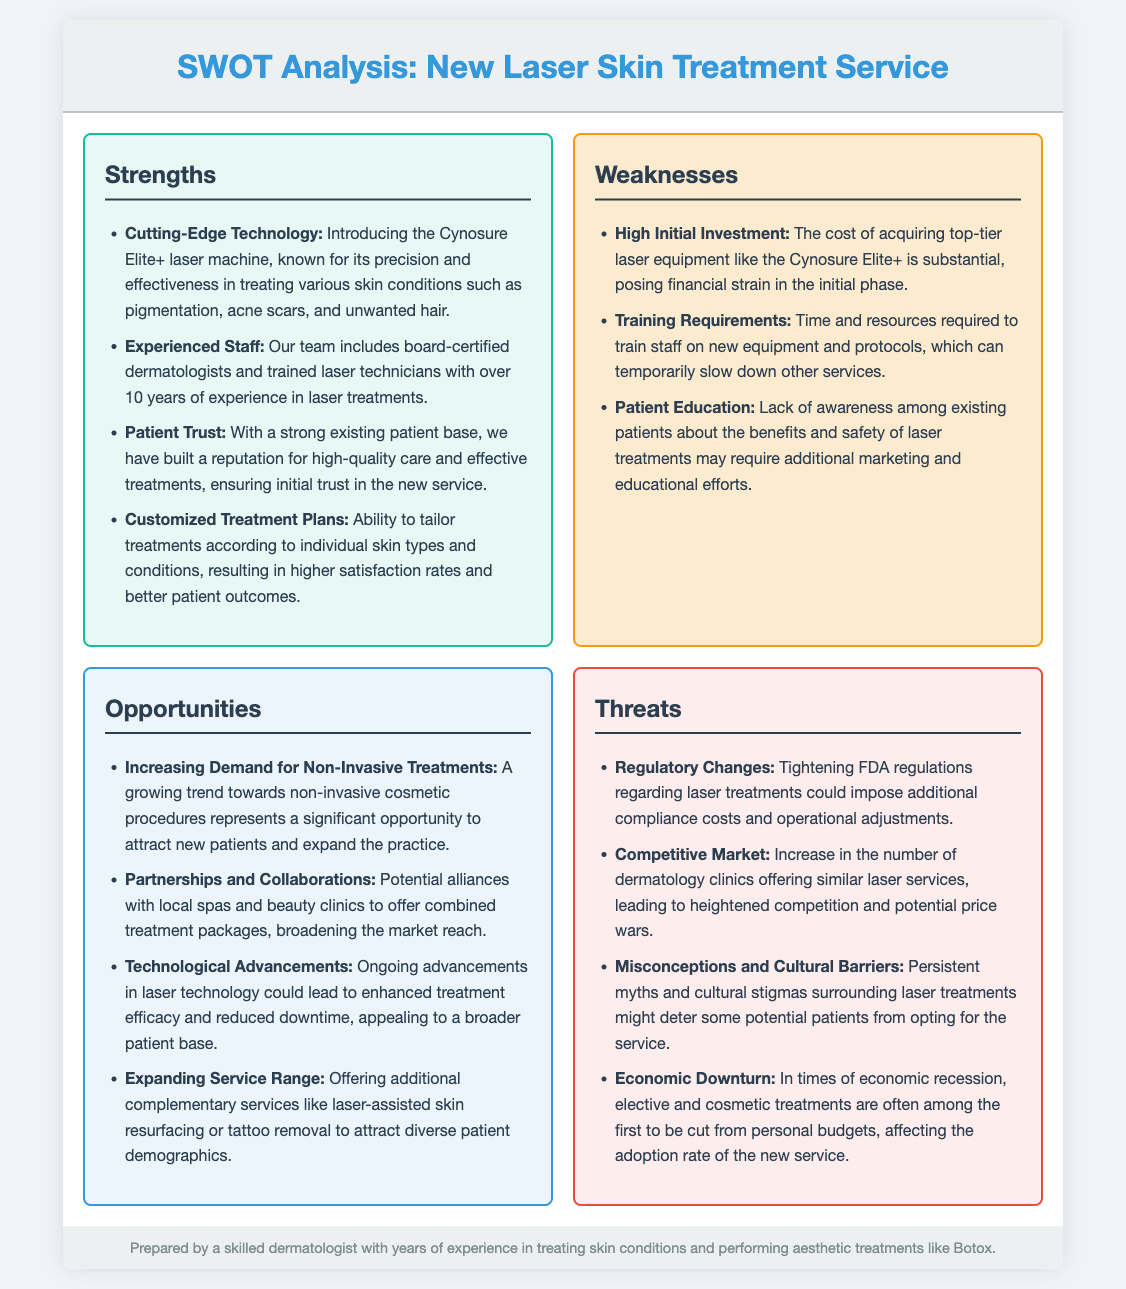what is the name of the laser machine introduced? The document mentions the Cynosure Elite+ laser machine as the new technology being introduced for skin treatment.
Answer: Cynosure Elite+ how many years of experience does the staff have collectively? The document highlights that the staff has over 10 years of experience in laser treatments.
Answer: Over 10 years what is the primary weakness associated with the new service? According to the document, the high initial investment for top-tier laser equipment is mentioned as a primary weakness.
Answer: High Initial Investment what opportunity is mentioned regarding local collaborations? The document discusses potential partnerships with local spas and beauty clinics to expand market reach.
Answer: Partnerships and Collaborations what cultural factor could impact patient decisions? The document indicates that persistent myths and cultural stigmas surrounding laser treatments might deter potential patients.
Answer: Misconceptions and Cultural Barriers how many specific threats are listed in the document? The document outlines four threats related to the new laser treatment service.
Answer: Four what is one strength related to patient satisfaction? The document indicates that customized treatment plans lead to higher satisfaction rates and better patient outcomes.
Answer: Customized Treatment Plans what is a potential result of economic downturn for the service? The document states that elective and cosmetic treatments are often cut from personal budgets during economic recessions.
Answer: Affected adoption rate 